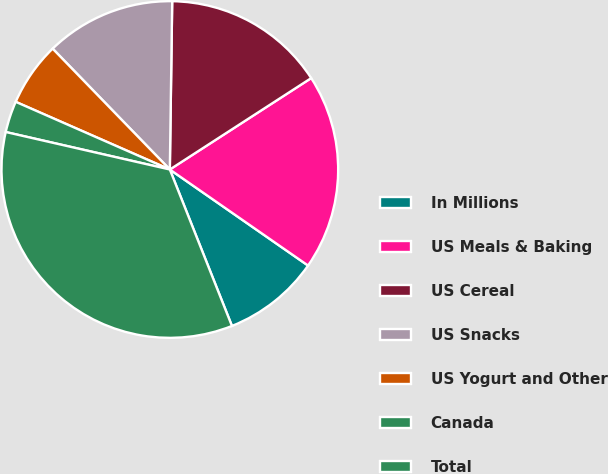Convert chart to OTSL. <chart><loc_0><loc_0><loc_500><loc_500><pie_chart><fcel>In Millions<fcel>US Meals & Baking<fcel>US Cereal<fcel>US Snacks<fcel>US Yogurt and Other<fcel>Canada<fcel>Total<nl><fcel>9.32%<fcel>18.8%<fcel>15.64%<fcel>12.48%<fcel>6.16%<fcel>3.01%<fcel>34.59%<nl></chart> 